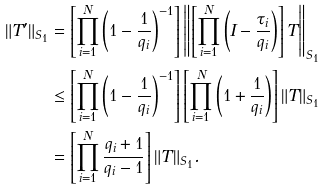<formula> <loc_0><loc_0><loc_500><loc_500>\| T ^ { \prime } \| _ { S _ { 1 } } & = \left [ \prod _ { i = 1 } ^ { N } \left ( 1 - \frac { 1 } { q _ { i } } \right ) ^ { - 1 } \right ] \left \| \left [ \prod _ { i = 1 } ^ { N } \left ( I - \frac { \tau _ { i } } { q _ { i } } \right ) \right ] T \right \| _ { S _ { 1 } } \\ & \leq \left [ \prod _ { i = 1 } ^ { N } \left ( 1 - \frac { 1 } { q _ { i } } \right ) ^ { - 1 } \right ] \left [ \prod _ { i = 1 } ^ { N } \left ( 1 + \frac { 1 } { q _ { i } } \right ) \right ] \| T \| _ { S _ { 1 } } \\ & = \left [ \prod _ { i = 1 } ^ { N } \frac { q _ { i } + 1 } { q _ { i } - 1 } \right ] \| T \| _ { S _ { 1 } } .</formula> 